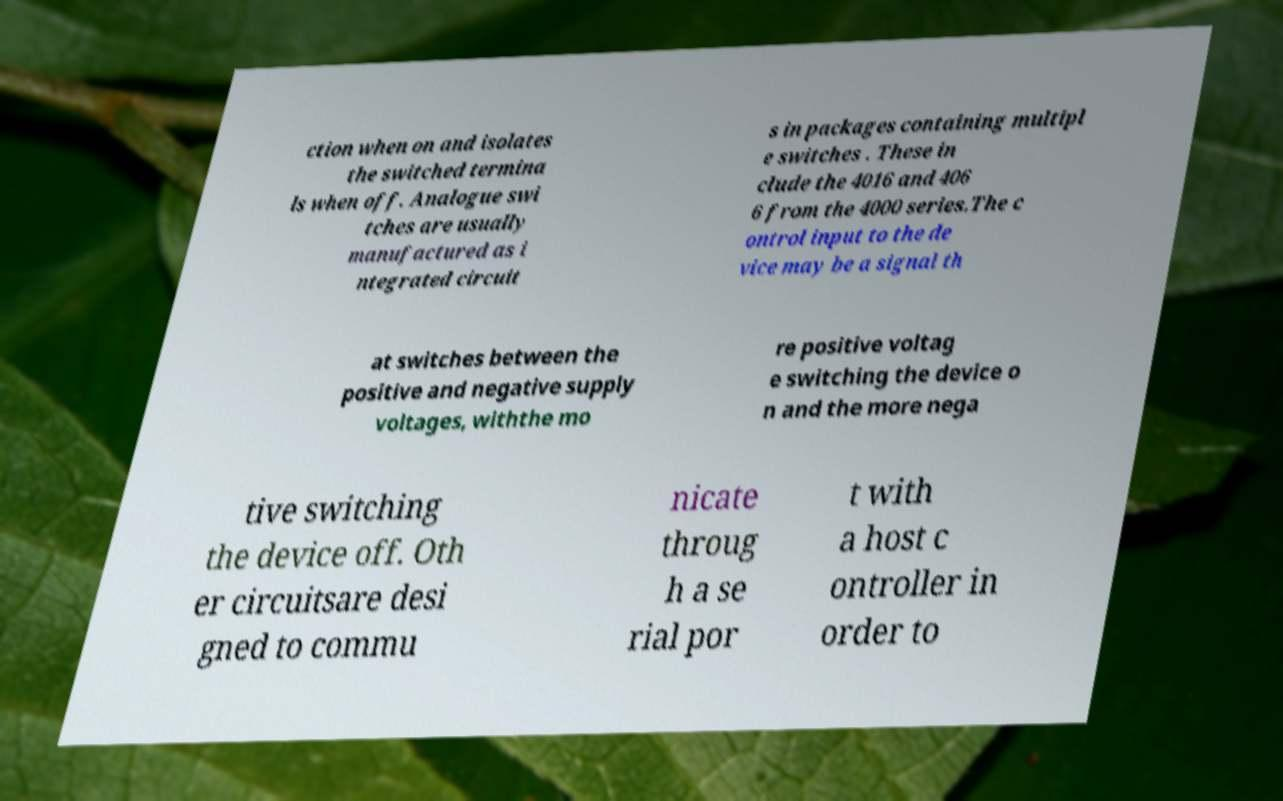There's text embedded in this image that I need extracted. Can you transcribe it verbatim? ction when on and isolates the switched termina ls when off. Analogue swi tches are usually manufactured as i ntegrated circuit s in packages containing multipl e switches . These in clude the 4016 and 406 6 from the 4000 series.The c ontrol input to the de vice may be a signal th at switches between the positive and negative supply voltages, withthe mo re positive voltag e switching the device o n and the more nega tive switching the device off. Oth er circuitsare desi gned to commu nicate throug h a se rial por t with a host c ontroller in order to 